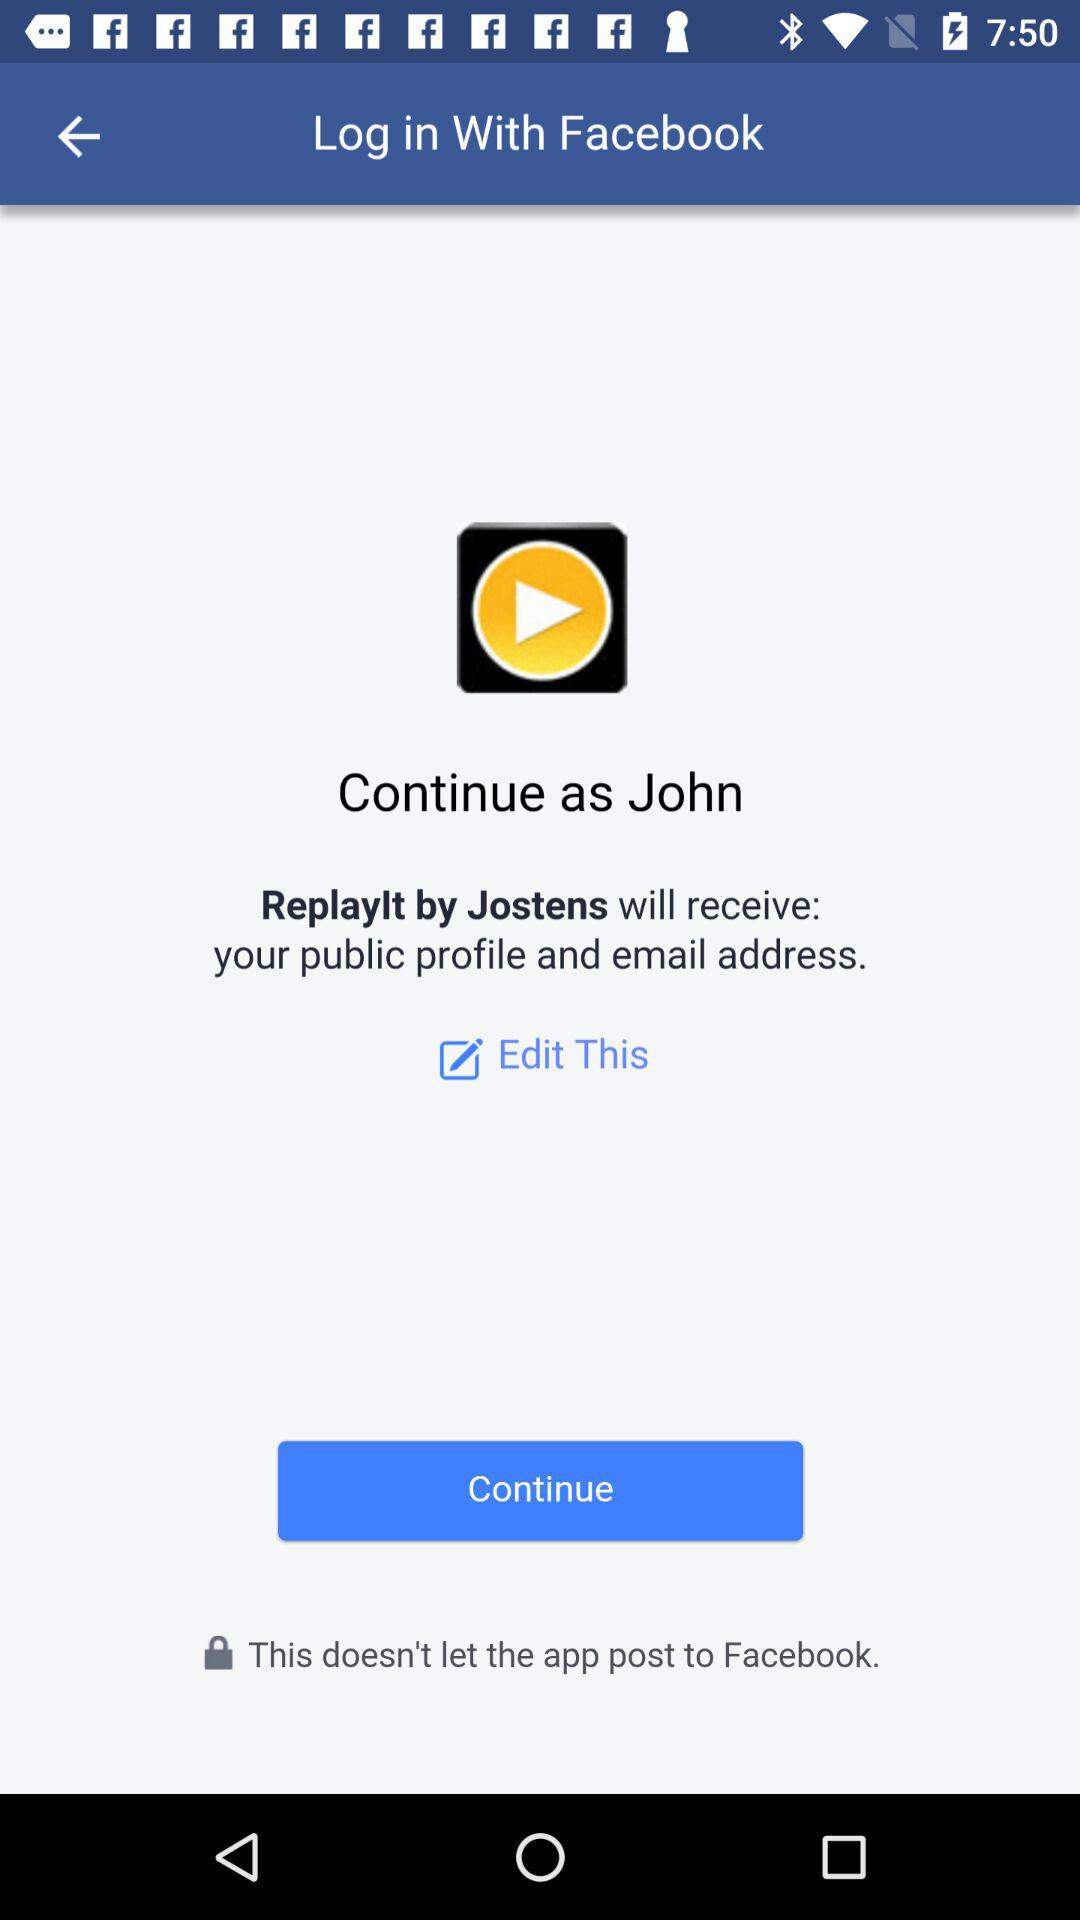What application is asking for permission? The application asking for permission is "Replaylt by Jostens". 